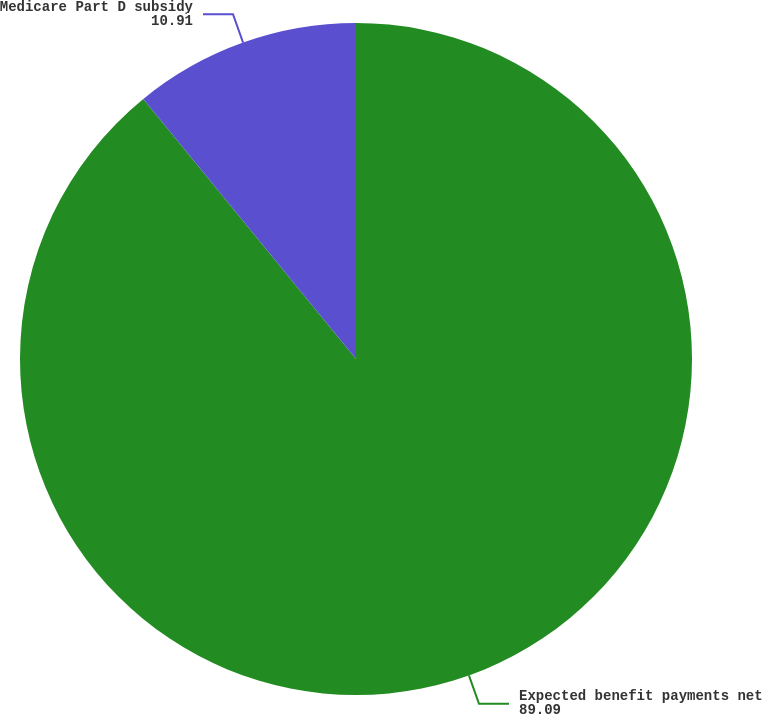Convert chart. <chart><loc_0><loc_0><loc_500><loc_500><pie_chart><fcel>Expected benefit payments net<fcel>Medicare Part D subsidy<nl><fcel>89.09%<fcel>10.91%<nl></chart> 